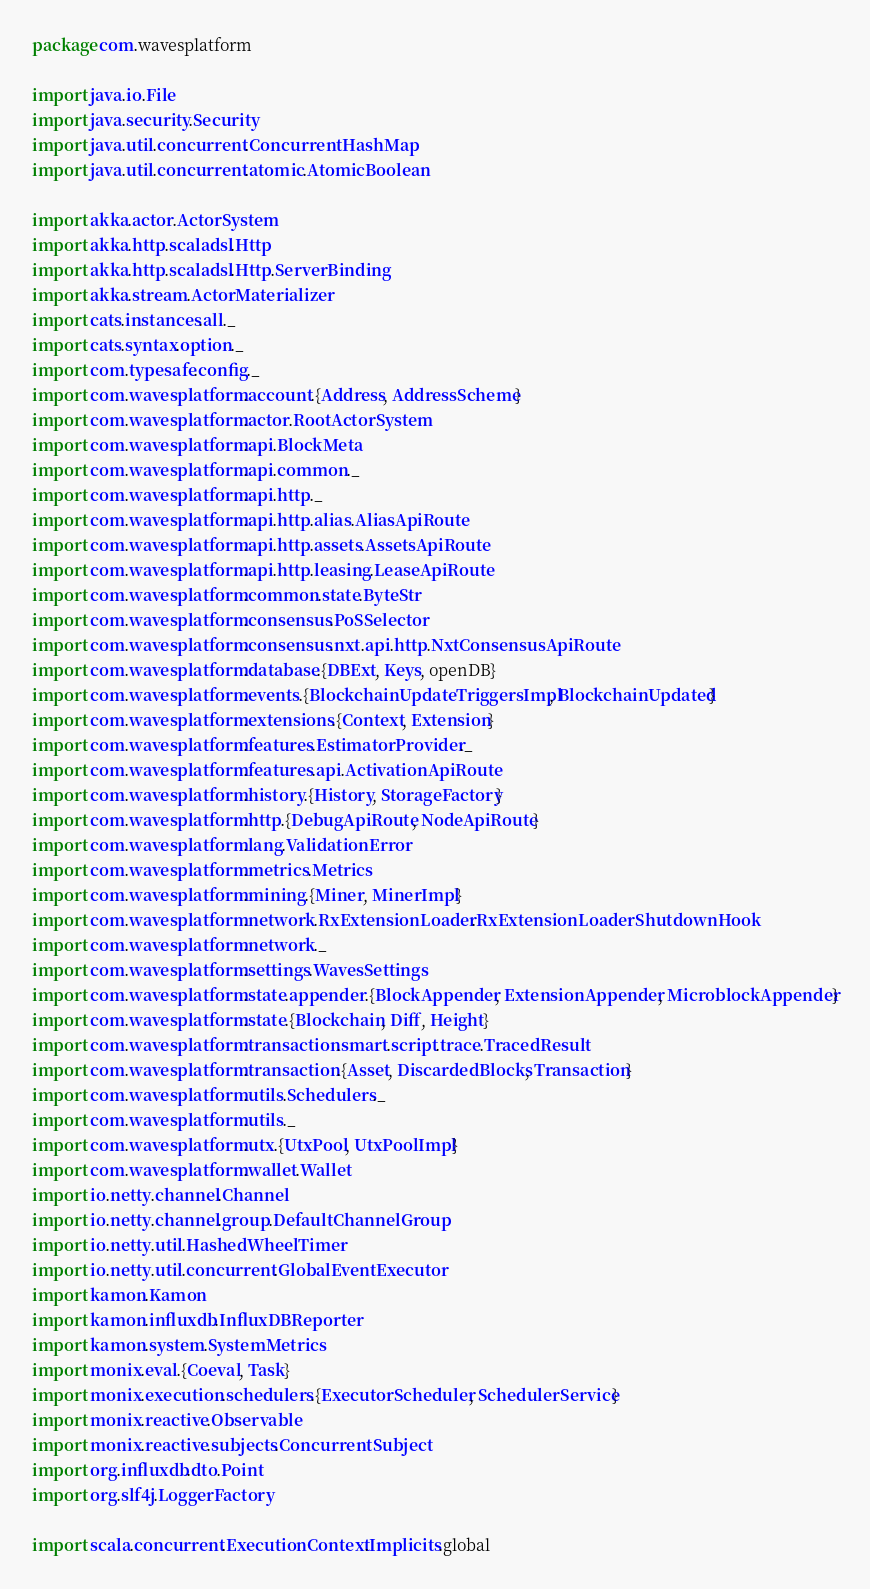Convert code to text. <code><loc_0><loc_0><loc_500><loc_500><_Scala_>package com.wavesplatform

import java.io.File
import java.security.Security
import java.util.concurrent.ConcurrentHashMap
import java.util.concurrent.atomic.AtomicBoolean

import akka.actor.ActorSystem
import akka.http.scaladsl.Http
import akka.http.scaladsl.Http.ServerBinding
import akka.stream.ActorMaterializer
import cats.instances.all._
import cats.syntax.option._
import com.typesafe.config._
import com.wavesplatform.account.{Address, AddressScheme}
import com.wavesplatform.actor.RootActorSystem
import com.wavesplatform.api.BlockMeta
import com.wavesplatform.api.common._
import com.wavesplatform.api.http._
import com.wavesplatform.api.http.alias.AliasApiRoute
import com.wavesplatform.api.http.assets.AssetsApiRoute
import com.wavesplatform.api.http.leasing.LeaseApiRoute
import com.wavesplatform.common.state.ByteStr
import com.wavesplatform.consensus.PoSSelector
import com.wavesplatform.consensus.nxt.api.http.NxtConsensusApiRoute
import com.wavesplatform.database.{DBExt, Keys, openDB}
import com.wavesplatform.events.{BlockchainUpdateTriggersImpl, BlockchainUpdated}
import com.wavesplatform.extensions.{Context, Extension}
import com.wavesplatform.features.EstimatorProvider._
import com.wavesplatform.features.api.ActivationApiRoute
import com.wavesplatform.history.{History, StorageFactory}
import com.wavesplatform.http.{DebugApiRoute, NodeApiRoute}
import com.wavesplatform.lang.ValidationError
import com.wavesplatform.metrics.Metrics
import com.wavesplatform.mining.{Miner, MinerImpl}
import com.wavesplatform.network.RxExtensionLoader.RxExtensionLoaderShutdownHook
import com.wavesplatform.network._
import com.wavesplatform.settings.WavesSettings
import com.wavesplatform.state.appender.{BlockAppender, ExtensionAppender, MicroblockAppender}
import com.wavesplatform.state.{Blockchain, Diff, Height}
import com.wavesplatform.transaction.smart.script.trace.TracedResult
import com.wavesplatform.transaction.{Asset, DiscardedBlocks, Transaction}
import com.wavesplatform.utils.Schedulers._
import com.wavesplatform.utils._
import com.wavesplatform.utx.{UtxPool, UtxPoolImpl}
import com.wavesplatform.wallet.Wallet
import io.netty.channel.Channel
import io.netty.channel.group.DefaultChannelGroup
import io.netty.util.HashedWheelTimer
import io.netty.util.concurrent.GlobalEventExecutor
import kamon.Kamon
import kamon.influxdb.InfluxDBReporter
import kamon.system.SystemMetrics
import monix.eval.{Coeval, Task}
import monix.execution.schedulers.{ExecutorScheduler, SchedulerService}
import monix.reactive.Observable
import monix.reactive.subjects.ConcurrentSubject
import org.influxdb.dto.Point
import org.slf4j.LoggerFactory

import scala.concurrent.ExecutionContext.Implicits.global</code> 